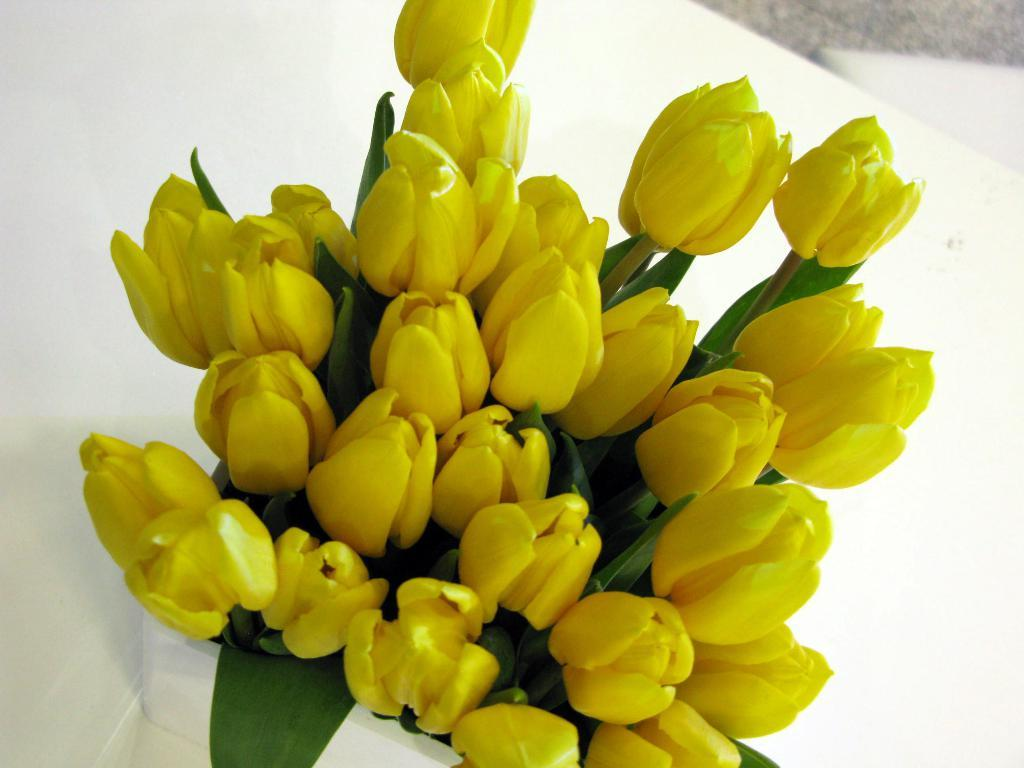What is the main object in the image? There is a pot in the image. What is the color of the surface the pot is on? The pot is on a white surface. What type of plants are in the pot? There are yellow flowers and green leaves in the pot. Are there any other parts of the plants visible in the pot? Yes, there are stems in the pot. What books are being read by the flowers in the pot? There are no books or reading activity depicted in the image; it features a pot with yellow flowers, green leaves, and stems. 